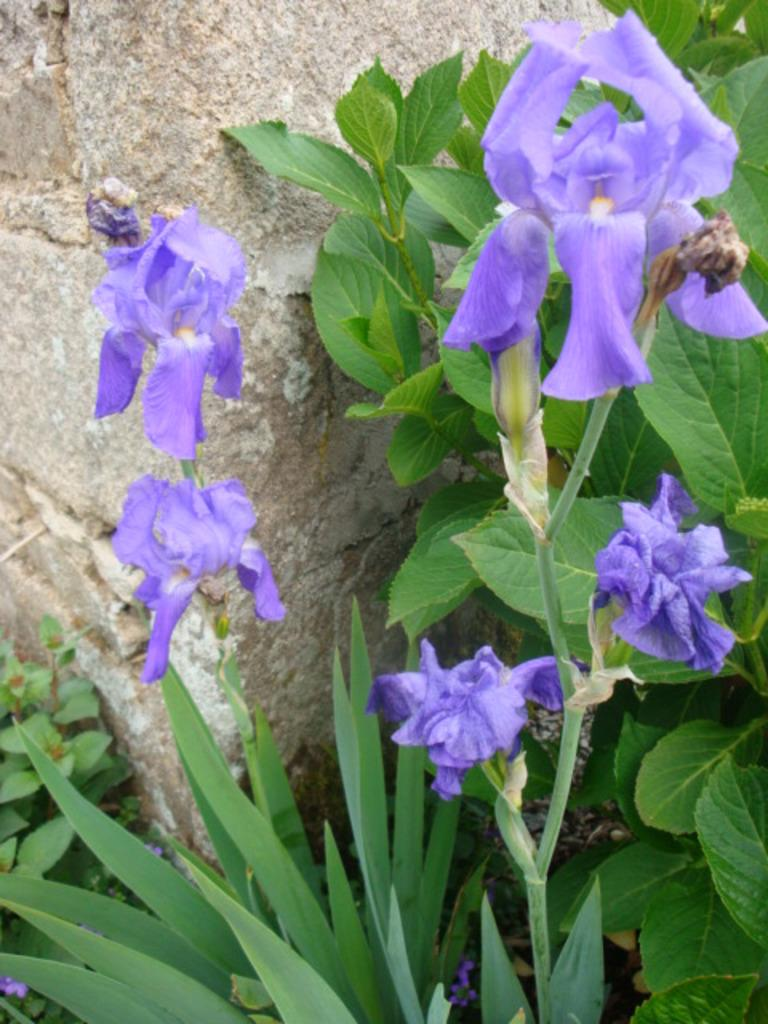What type of vegetation is present in the image? There are flowers and leaves in the image. Can you describe the background of the image? There is a wall in the background of the image. What type of underwear is being distributed in the image? There is no underwear or distribution process present in the image. 